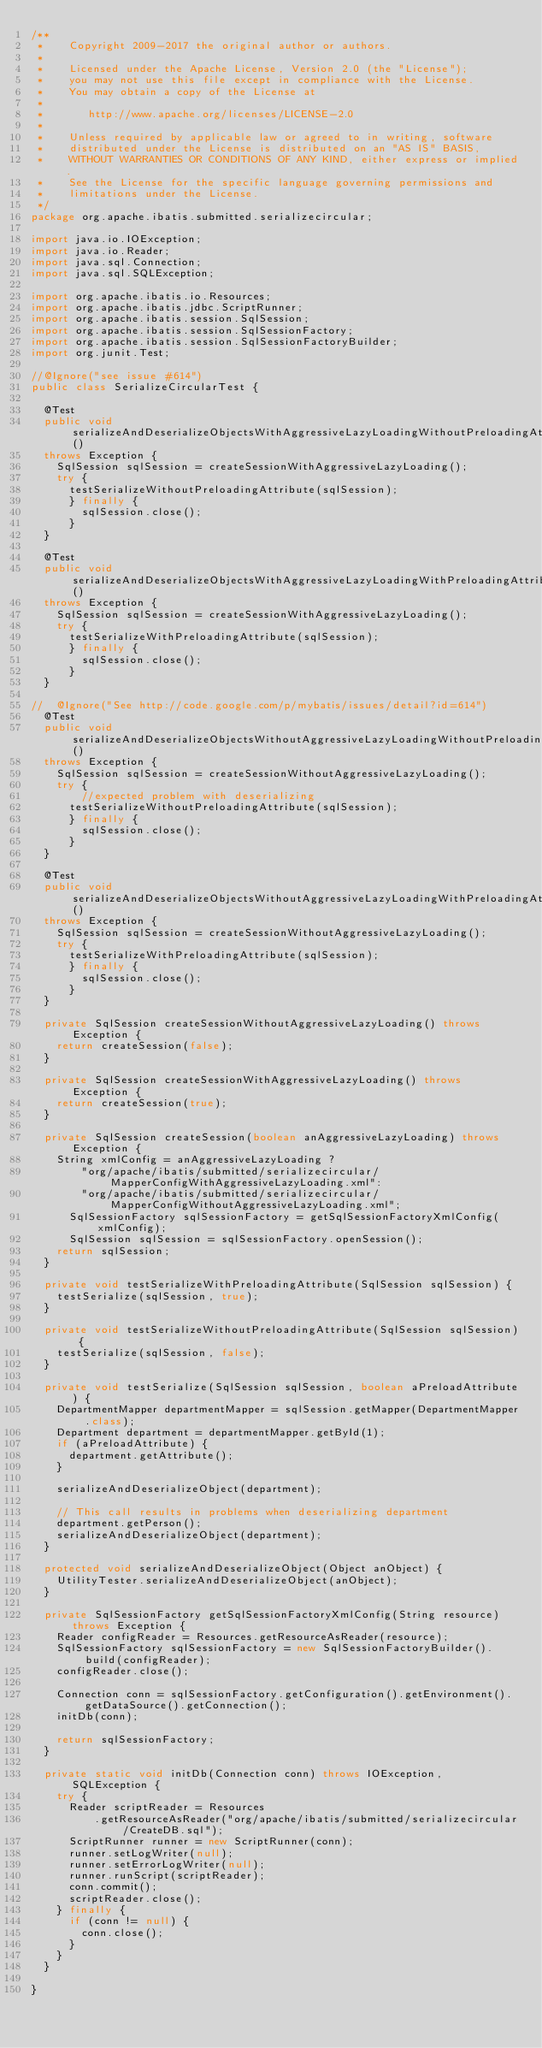Convert code to text. <code><loc_0><loc_0><loc_500><loc_500><_Java_>/**
 *    Copyright 2009-2017 the original author or authors.
 *
 *    Licensed under the Apache License, Version 2.0 (the "License");
 *    you may not use this file except in compliance with the License.
 *    You may obtain a copy of the License at
 *
 *       http://www.apache.org/licenses/LICENSE-2.0
 *
 *    Unless required by applicable law or agreed to in writing, software
 *    distributed under the License is distributed on an "AS IS" BASIS,
 *    WITHOUT WARRANTIES OR CONDITIONS OF ANY KIND, either express or implied.
 *    See the License for the specific language governing permissions and
 *    limitations under the License.
 */
package org.apache.ibatis.submitted.serializecircular;

import java.io.IOException;
import java.io.Reader;
import java.sql.Connection;
import java.sql.SQLException;

import org.apache.ibatis.io.Resources;
import org.apache.ibatis.jdbc.ScriptRunner;
import org.apache.ibatis.session.SqlSession;
import org.apache.ibatis.session.SqlSessionFactory;
import org.apache.ibatis.session.SqlSessionFactoryBuilder;
import org.junit.Test;

//@Ignore("see issue #614")
public class SerializeCircularTest {

  @Test
  public void serializeAndDeserializeObjectsWithAggressiveLazyLoadingWithoutPreloadingAttribute() 
  throws Exception {
    SqlSession sqlSession = createSessionWithAggressiveLazyLoading();
    try {
      testSerializeWithoutPreloadingAttribute(sqlSession);
      } finally {
        sqlSession.close();
      }
  }
  
  @Test
  public void serializeAndDeserializeObjectsWithAggressiveLazyLoadingWithPreloadingAttribute() 
  throws Exception {
    SqlSession sqlSession = createSessionWithAggressiveLazyLoading();
    try {
      testSerializeWithPreloadingAttribute(sqlSession);
      } finally {
        sqlSession.close();
      }
  }

//  @Ignore("See http://code.google.com/p/mybatis/issues/detail?id=614")
  @Test
  public void serializeAndDeserializeObjectsWithoutAggressiveLazyLoadingWithoutPreloadingAttribute() 
  throws Exception {
    SqlSession sqlSession = createSessionWithoutAggressiveLazyLoading();
    try {
        //expected problem with deserializing
      testSerializeWithoutPreloadingAttribute(sqlSession);
      } finally {
        sqlSession.close();
      }
  }

  @Test
  public void serializeAndDeserializeObjectsWithoutAggressiveLazyLoadingWithPreloadingAttribute() 
  throws Exception {
    SqlSession sqlSession = createSessionWithoutAggressiveLazyLoading();
    try {
      testSerializeWithPreloadingAttribute(sqlSession);
      } finally {
        sqlSession.close();
      }
  }

  private SqlSession createSessionWithoutAggressiveLazyLoading() throws Exception {
    return createSession(false);
  }

  private SqlSession createSessionWithAggressiveLazyLoading() throws Exception {
    return createSession(true);
  }

  private SqlSession createSession(boolean anAggressiveLazyLoading) throws Exception {
    String xmlConfig = anAggressiveLazyLoading ?
        "org/apache/ibatis/submitted/serializecircular/MapperConfigWithAggressiveLazyLoading.xml":
        "org/apache/ibatis/submitted/serializecircular/MapperConfigWithoutAggressiveLazyLoading.xml";
      SqlSessionFactory sqlSessionFactory = getSqlSessionFactoryXmlConfig(xmlConfig);
      SqlSession sqlSession = sqlSessionFactory.openSession();
    return sqlSession;
  }

  private void testSerializeWithPreloadingAttribute(SqlSession sqlSession) {
    testSerialize(sqlSession, true);
  }

  private void testSerializeWithoutPreloadingAttribute(SqlSession sqlSession) {
    testSerialize(sqlSession, false);
  }

  private void testSerialize(SqlSession sqlSession, boolean aPreloadAttribute) {
    DepartmentMapper departmentMapper = sqlSession.getMapper(DepartmentMapper.class);
    Department department = departmentMapper.getById(1);
    if (aPreloadAttribute) {
      department.getAttribute();
    }

    serializeAndDeserializeObject(department);

    // This call results in problems when deserializing department
    department.getPerson();
    serializeAndDeserializeObject(department);
  }

  protected void serializeAndDeserializeObject(Object anObject) {
    UtilityTester.serializeAndDeserializeObject(anObject);
  }

  private SqlSessionFactory getSqlSessionFactoryXmlConfig(String resource) throws Exception {
    Reader configReader = Resources.getResourceAsReader(resource);
    SqlSessionFactory sqlSessionFactory = new SqlSessionFactoryBuilder().build(configReader);
    configReader.close();

    Connection conn = sqlSessionFactory.getConfiguration().getEnvironment().getDataSource().getConnection();
    initDb(conn);

    return sqlSessionFactory;
  }

  private static void initDb(Connection conn) throws IOException, SQLException {
    try {
      Reader scriptReader = Resources
          .getResourceAsReader("org/apache/ibatis/submitted/serializecircular/CreateDB.sql");
      ScriptRunner runner = new ScriptRunner(conn);
      runner.setLogWriter(null);
      runner.setErrorLogWriter(null);
      runner.runScript(scriptReader);
      conn.commit();
      scriptReader.close();
    } finally {
      if (conn != null) {
        conn.close();
      }
    }
  }

}
</code> 